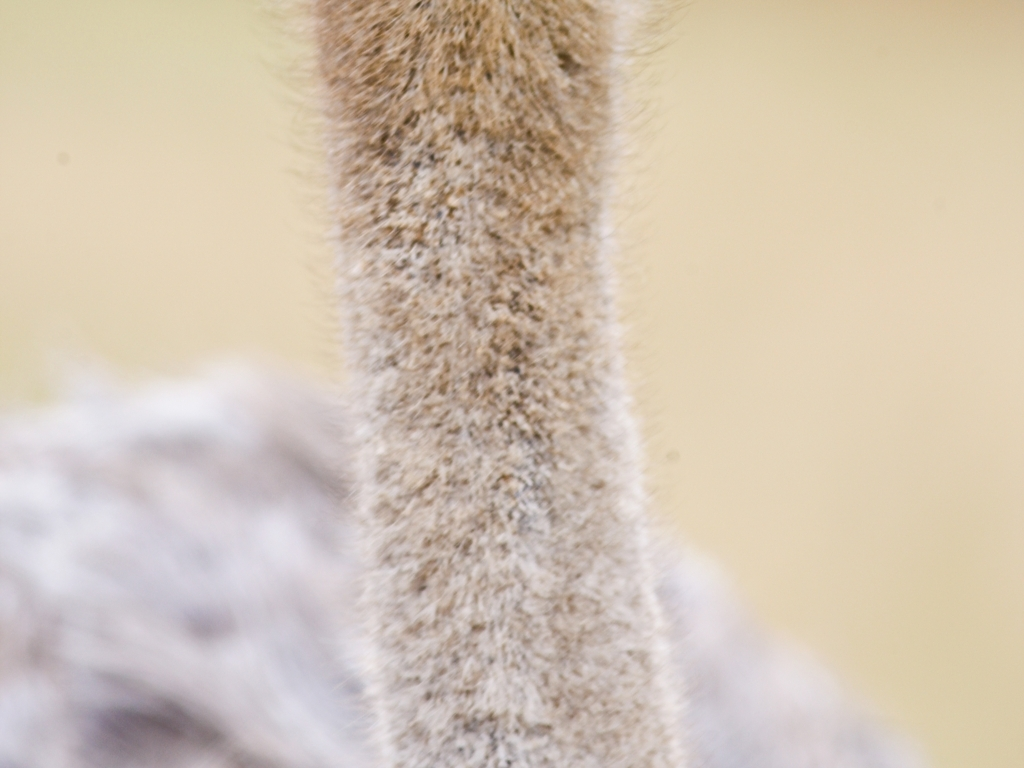Could this image quality be a result of motion? Yes, the blurred quality could potentially be a result of motion, whether it's the subject moving quickly, or the camera itself being moved during the exposure, particularly if the shutter speed was not fast enough to freeze the motion. If it's motion blur, what can be done to correct this in future photographs? To prevent motion blur, one can use a faster shutter speed, increase the camera sensor's sensitivity settings (ISO), and ensure stabilization either by using a tripod or a lens with image stabilization features. 